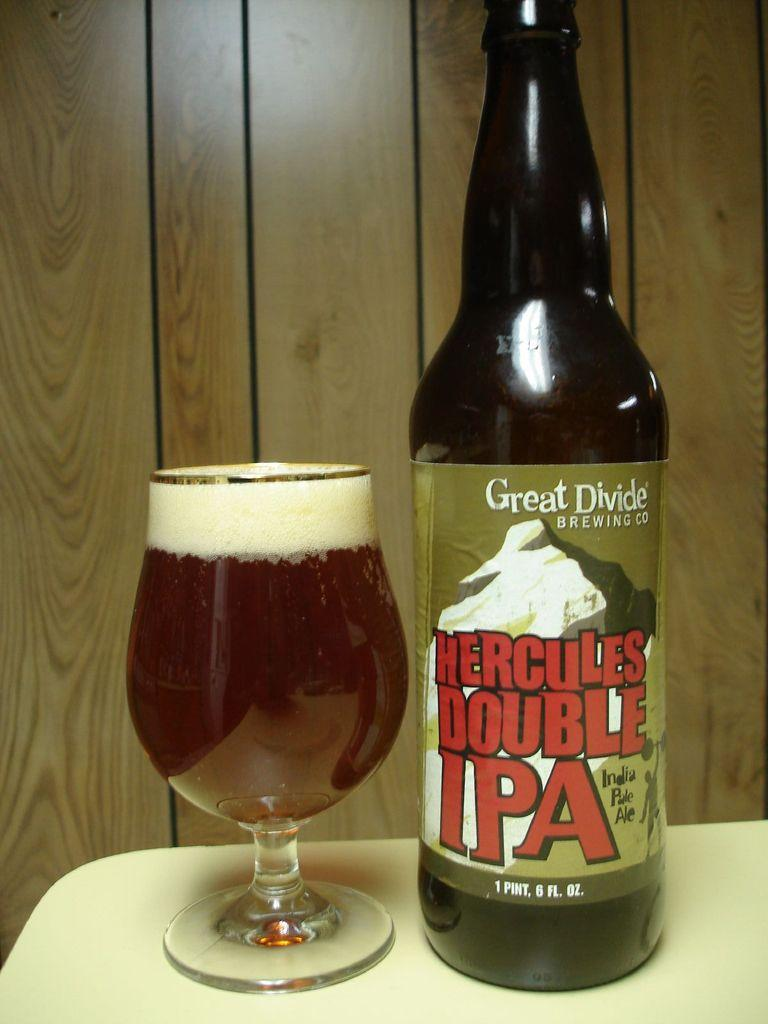<image>
Render a clear and concise summary of the photo. A beer bottle has a label reading HERCULES DOUBLE IPA on it. 